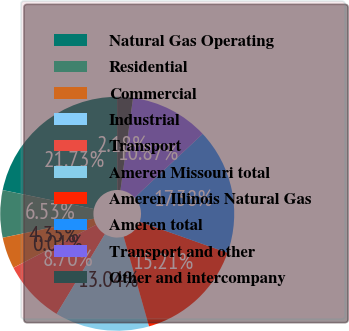<chart> <loc_0><loc_0><loc_500><loc_500><pie_chart><fcel>Natural Gas Operating<fcel>Residential<fcel>Commercial<fcel>Industrial<fcel>Transport<fcel>Ameren Missouri total<fcel>Ameren Illinois Natural Gas<fcel>Ameren total<fcel>Transport and other<fcel>Other and intercompany<nl><fcel>21.73%<fcel>6.53%<fcel>4.35%<fcel>0.01%<fcel>8.7%<fcel>13.04%<fcel>15.21%<fcel>17.38%<fcel>10.87%<fcel>2.18%<nl></chart> 